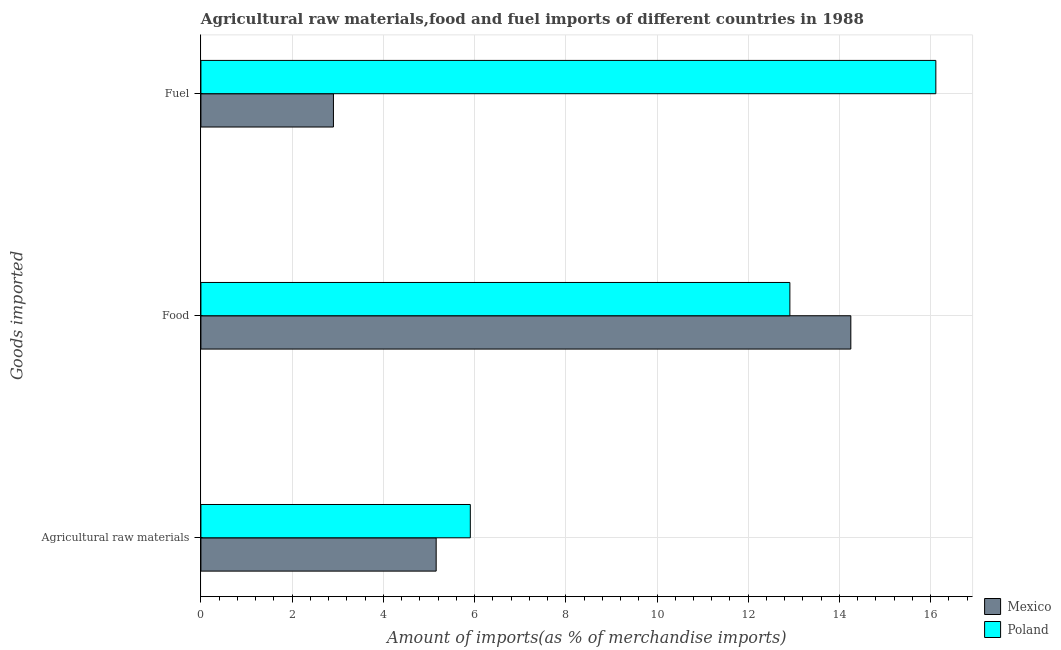How many different coloured bars are there?
Provide a succinct answer. 2. How many groups of bars are there?
Your response must be concise. 3. How many bars are there on the 3rd tick from the top?
Make the answer very short. 2. What is the label of the 2nd group of bars from the top?
Provide a short and direct response. Food. What is the percentage of food imports in Poland?
Make the answer very short. 12.91. Across all countries, what is the maximum percentage of fuel imports?
Your answer should be very brief. 16.11. Across all countries, what is the minimum percentage of fuel imports?
Ensure brevity in your answer.  2.91. In which country was the percentage of fuel imports maximum?
Keep it short and to the point. Poland. What is the total percentage of fuel imports in the graph?
Provide a short and direct response. 19.02. What is the difference between the percentage of food imports in Poland and that in Mexico?
Provide a succinct answer. -1.34. What is the difference between the percentage of food imports in Poland and the percentage of raw materials imports in Mexico?
Provide a succinct answer. 7.76. What is the average percentage of raw materials imports per country?
Provide a succinct answer. 5.53. What is the difference between the percentage of fuel imports and percentage of food imports in Poland?
Give a very brief answer. 3.2. In how many countries, is the percentage of raw materials imports greater than 10.4 %?
Offer a terse response. 0. What is the ratio of the percentage of food imports in Poland to that in Mexico?
Make the answer very short. 0.91. What is the difference between the highest and the second highest percentage of raw materials imports?
Provide a short and direct response. 0.75. What is the difference between the highest and the lowest percentage of raw materials imports?
Ensure brevity in your answer.  0.75. In how many countries, is the percentage of fuel imports greater than the average percentage of fuel imports taken over all countries?
Offer a very short reply. 1. Is it the case that in every country, the sum of the percentage of raw materials imports and percentage of food imports is greater than the percentage of fuel imports?
Provide a short and direct response. Yes. What is the difference between two consecutive major ticks on the X-axis?
Give a very brief answer. 2. Are the values on the major ticks of X-axis written in scientific E-notation?
Offer a very short reply. No. Does the graph contain any zero values?
Offer a terse response. No. Does the graph contain grids?
Your response must be concise. Yes. Where does the legend appear in the graph?
Your answer should be compact. Bottom right. How are the legend labels stacked?
Your response must be concise. Vertical. What is the title of the graph?
Ensure brevity in your answer.  Agricultural raw materials,food and fuel imports of different countries in 1988. Does "Samoa" appear as one of the legend labels in the graph?
Your answer should be very brief. No. What is the label or title of the X-axis?
Offer a terse response. Amount of imports(as % of merchandise imports). What is the label or title of the Y-axis?
Keep it short and to the point. Goods imported. What is the Amount of imports(as % of merchandise imports) of Mexico in Agricultural raw materials?
Offer a terse response. 5.16. What is the Amount of imports(as % of merchandise imports) in Poland in Agricultural raw materials?
Offer a terse response. 5.91. What is the Amount of imports(as % of merchandise imports) of Mexico in Food?
Keep it short and to the point. 14.25. What is the Amount of imports(as % of merchandise imports) of Poland in Food?
Make the answer very short. 12.91. What is the Amount of imports(as % of merchandise imports) of Mexico in Fuel?
Offer a terse response. 2.91. What is the Amount of imports(as % of merchandise imports) in Poland in Fuel?
Provide a succinct answer. 16.11. Across all Goods imported, what is the maximum Amount of imports(as % of merchandise imports) of Mexico?
Your response must be concise. 14.25. Across all Goods imported, what is the maximum Amount of imports(as % of merchandise imports) of Poland?
Ensure brevity in your answer.  16.11. Across all Goods imported, what is the minimum Amount of imports(as % of merchandise imports) in Mexico?
Provide a succinct answer. 2.91. Across all Goods imported, what is the minimum Amount of imports(as % of merchandise imports) in Poland?
Ensure brevity in your answer.  5.91. What is the total Amount of imports(as % of merchandise imports) in Mexico in the graph?
Your response must be concise. 22.31. What is the total Amount of imports(as % of merchandise imports) of Poland in the graph?
Ensure brevity in your answer.  34.93. What is the difference between the Amount of imports(as % of merchandise imports) in Mexico in Agricultural raw materials and that in Food?
Provide a short and direct response. -9.09. What is the difference between the Amount of imports(as % of merchandise imports) in Poland in Agricultural raw materials and that in Food?
Offer a terse response. -7.01. What is the difference between the Amount of imports(as % of merchandise imports) of Mexico in Agricultural raw materials and that in Fuel?
Make the answer very short. 2.25. What is the difference between the Amount of imports(as % of merchandise imports) of Poland in Agricultural raw materials and that in Fuel?
Your answer should be compact. -10.21. What is the difference between the Amount of imports(as % of merchandise imports) in Mexico in Food and that in Fuel?
Your response must be concise. 11.34. What is the difference between the Amount of imports(as % of merchandise imports) in Poland in Food and that in Fuel?
Offer a very short reply. -3.2. What is the difference between the Amount of imports(as % of merchandise imports) in Mexico in Agricultural raw materials and the Amount of imports(as % of merchandise imports) in Poland in Food?
Give a very brief answer. -7.76. What is the difference between the Amount of imports(as % of merchandise imports) in Mexico in Agricultural raw materials and the Amount of imports(as % of merchandise imports) in Poland in Fuel?
Ensure brevity in your answer.  -10.96. What is the difference between the Amount of imports(as % of merchandise imports) of Mexico in Food and the Amount of imports(as % of merchandise imports) of Poland in Fuel?
Provide a short and direct response. -1.86. What is the average Amount of imports(as % of merchandise imports) in Mexico per Goods imported?
Offer a terse response. 7.44. What is the average Amount of imports(as % of merchandise imports) of Poland per Goods imported?
Provide a short and direct response. 11.64. What is the difference between the Amount of imports(as % of merchandise imports) in Mexico and Amount of imports(as % of merchandise imports) in Poland in Agricultural raw materials?
Your answer should be very brief. -0.75. What is the difference between the Amount of imports(as % of merchandise imports) in Mexico and Amount of imports(as % of merchandise imports) in Poland in Food?
Make the answer very short. 1.34. What is the difference between the Amount of imports(as % of merchandise imports) of Mexico and Amount of imports(as % of merchandise imports) of Poland in Fuel?
Make the answer very short. -13.21. What is the ratio of the Amount of imports(as % of merchandise imports) in Mexico in Agricultural raw materials to that in Food?
Your answer should be compact. 0.36. What is the ratio of the Amount of imports(as % of merchandise imports) of Poland in Agricultural raw materials to that in Food?
Offer a terse response. 0.46. What is the ratio of the Amount of imports(as % of merchandise imports) in Mexico in Agricultural raw materials to that in Fuel?
Ensure brevity in your answer.  1.78. What is the ratio of the Amount of imports(as % of merchandise imports) of Poland in Agricultural raw materials to that in Fuel?
Give a very brief answer. 0.37. What is the ratio of the Amount of imports(as % of merchandise imports) in Mexico in Food to that in Fuel?
Make the answer very short. 4.9. What is the ratio of the Amount of imports(as % of merchandise imports) in Poland in Food to that in Fuel?
Provide a short and direct response. 0.8. What is the difference between the highest and the second highest Amount of imports(as % of merchandise imports) in Mexico?
Offer a very short reply. 9.09. What is the difference between the highest and the second highest Amount of imports(as % of merchandise imports) of Poland?
Your response must be concise. 3.2. What is the difference between the highest and the lowest Amount of imports(as % of merchandise imports) in Mexico?
Provide a short and direct response. 11.34. What is the difference between the highest and the lowest Amount of imports(as % of merchandise imports) of Poland?
Offer a very short reply. 10.21. 